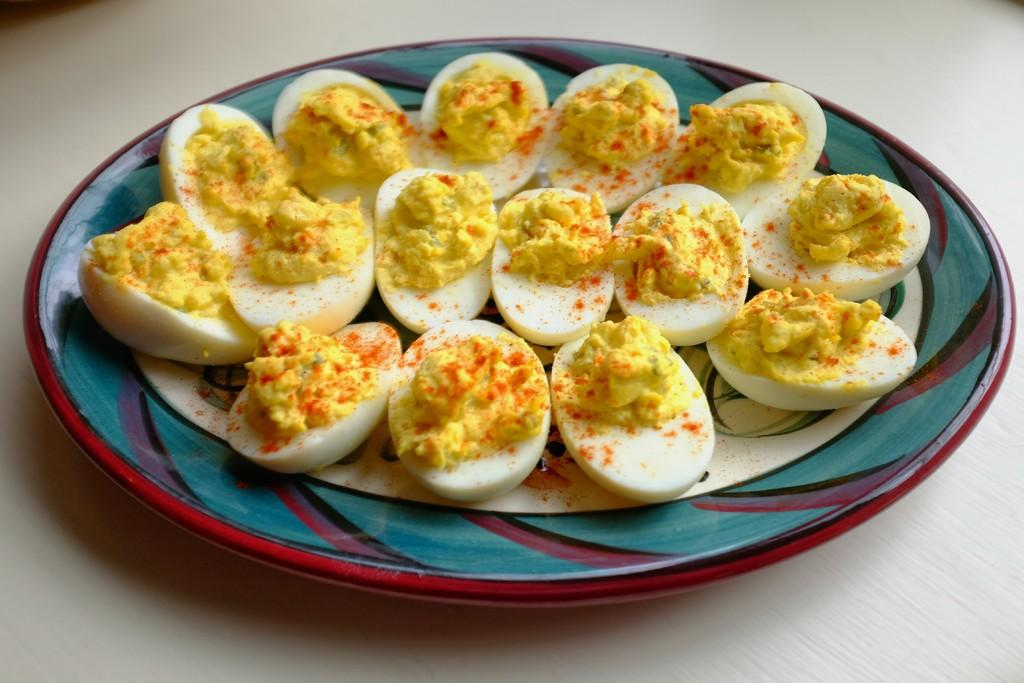What type of food is present in the image? There are boiled eggs in the image. How are the boiled eggs arranged in the image? The boiled eggs are in a plate. Where is the plate with boiled eggs located? The plate with boiled eggs is placed on a table. How many ants are crawling on the boiled eggs in the image? There are no ants present in the image; it only shows boiled eggs in a plate on a table. 